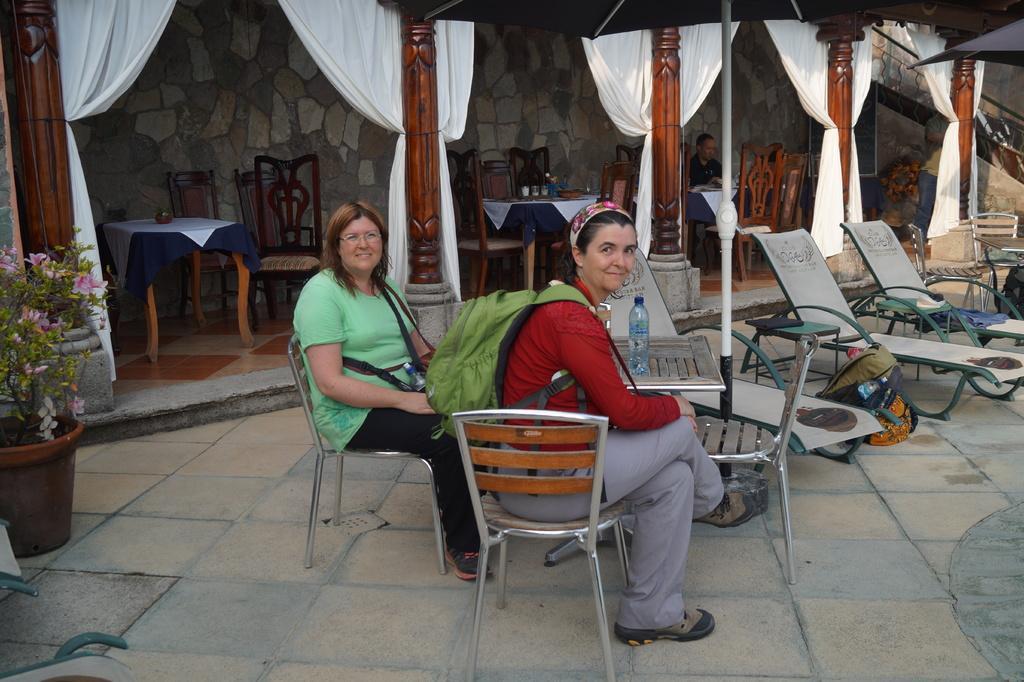Could you give a brief overview of what you see in this image? In this picture we have two Women's are sitting on the chair and they are carrying a bags in front of them there is a table on the table we have bottles glasses and so many chairs and tables are been arranged at the left side there is a potted plant and background we can see a person sitting on the chair. 